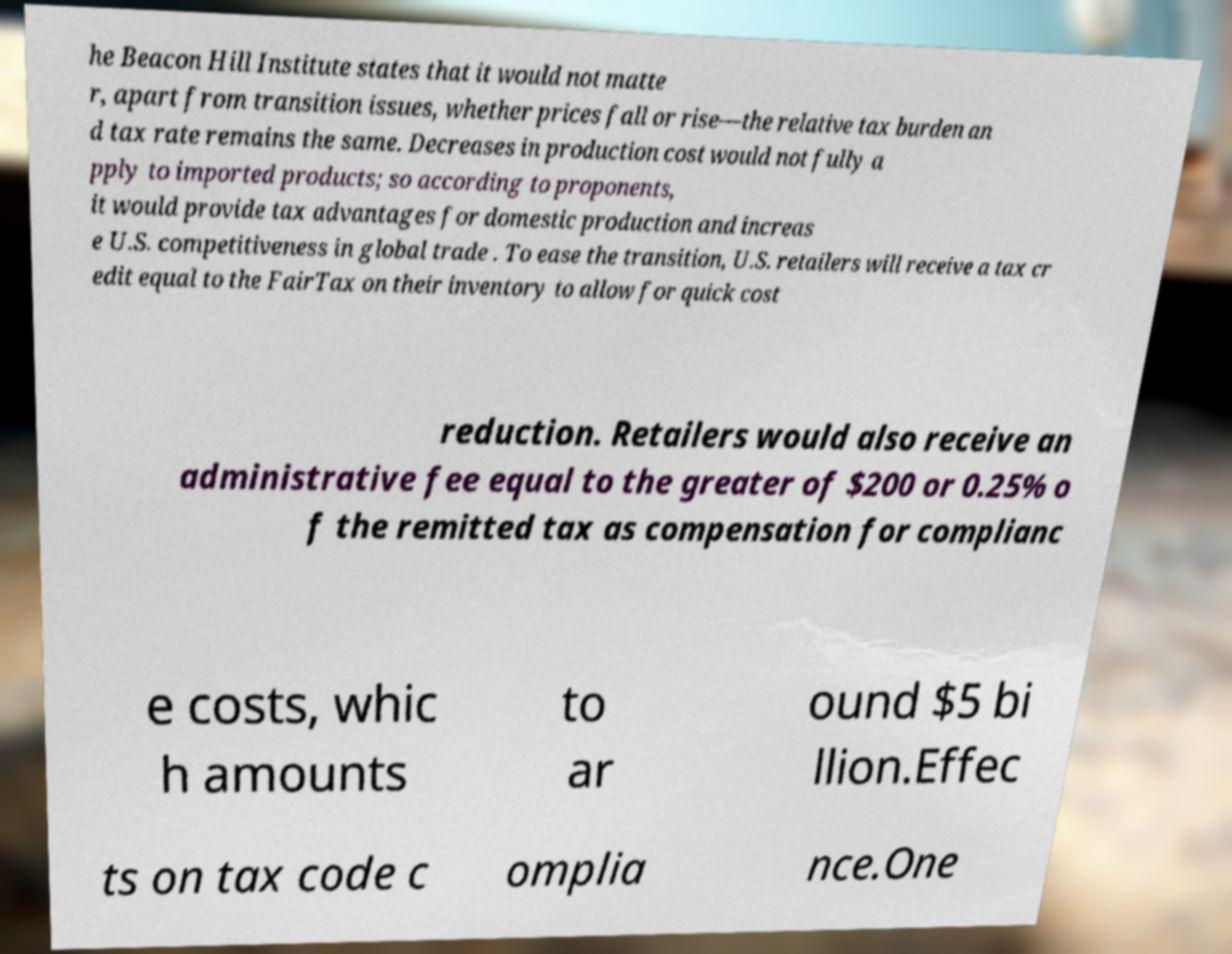Please read and relay the text visible in this image. What does it say? he Beacon Hill Institute states that it would not matte r, apart from transition issues, whether prices fall or rise—the relative tax burden an d tax rate remains the same. Decreases in production cost would not fully a pply to imported products; so according to proponents, it would provide tax advantages for domestic production and increas e U.S. competitiveness in global trade . To ease the transition, U.S. retailers will receive a tax cr edit equal to the FairTax on their inventory to allow for quick cost reduction. Retailers would also receive an administrative fee equal to the greater of $200 or 0.25% o f the remitted tax as compensation for complianc e costs, whic h amounts to ar ound $5 bi llion.Effec ts on tax code c omplia nce.One 